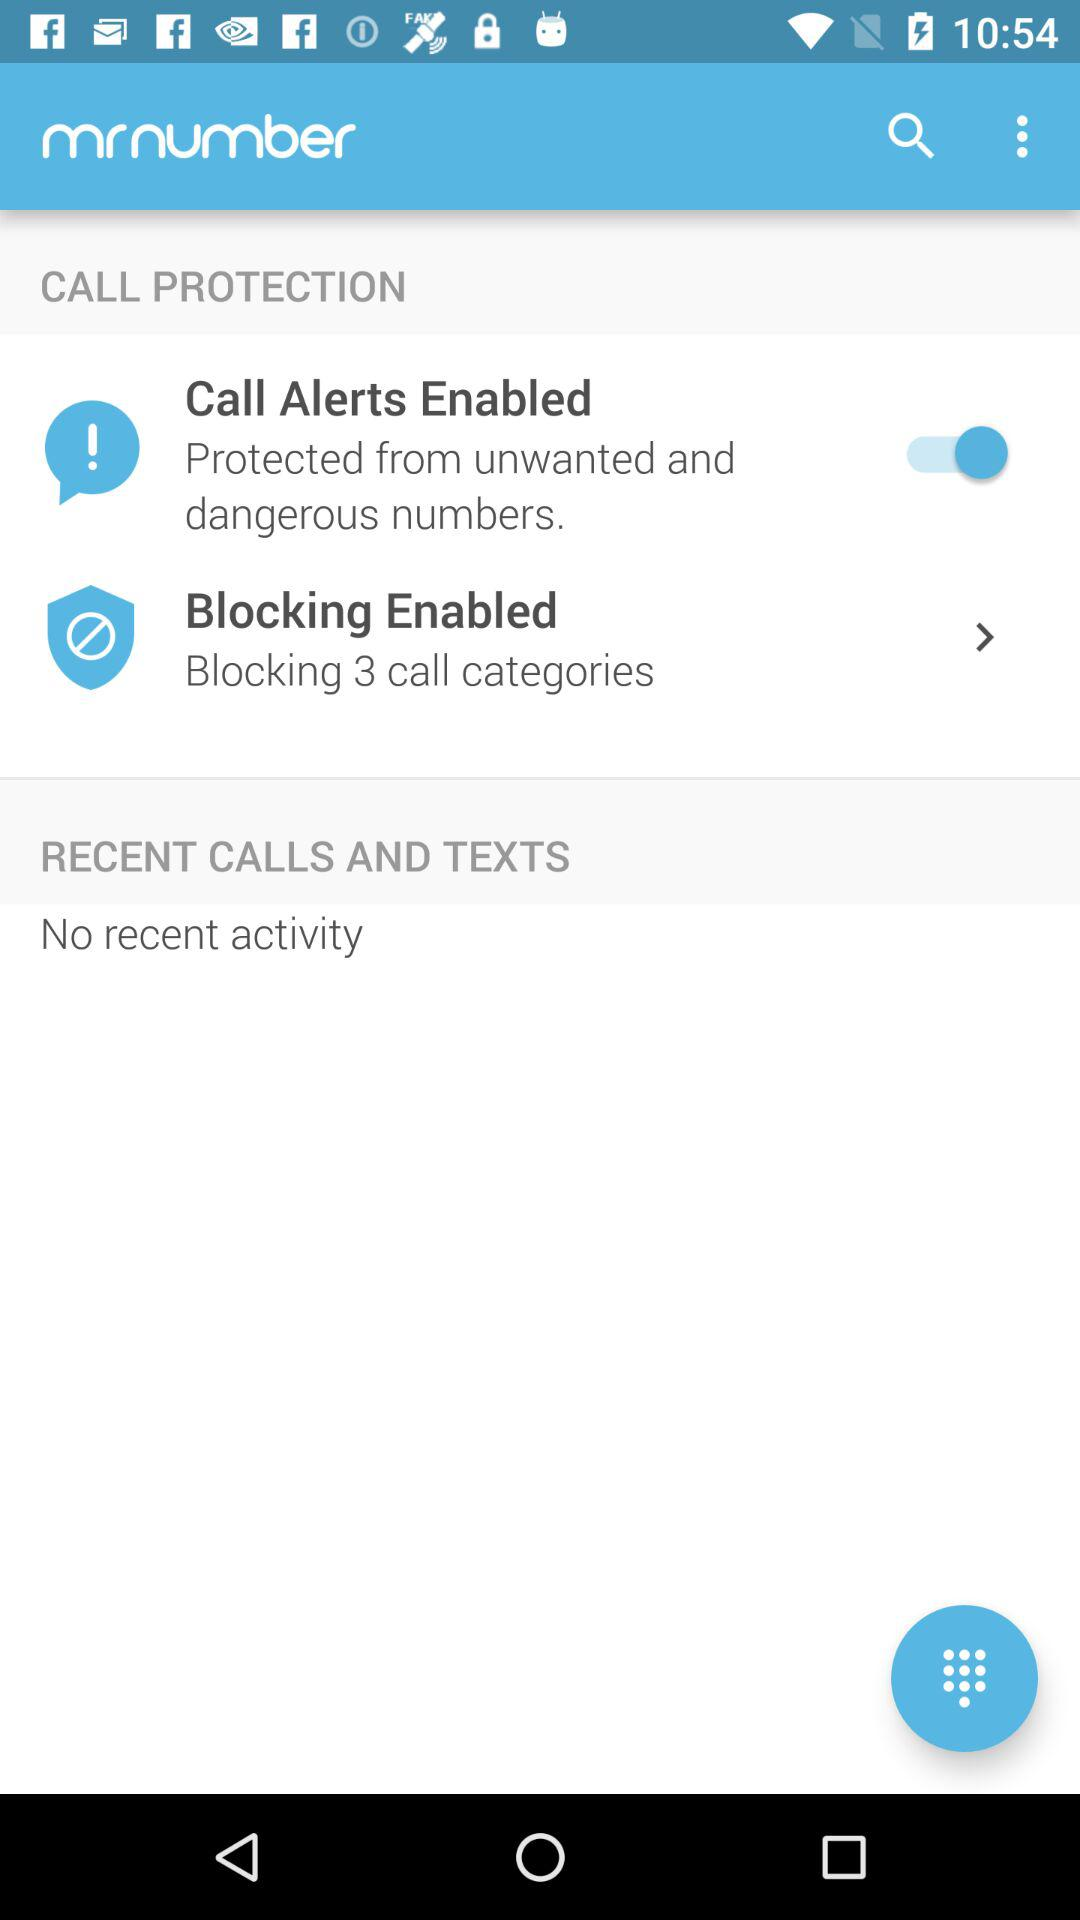What is the name of the application? The name of the application is "mrnumber". 